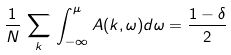<formula> <loc_0><loc_0><loc_500><loc_500>\frac { 1 } { N } \, \sum _ { k } \, \int _ { - \infty } ^ { \mu } A ( { k } , \omega ) d \omega = \frac { 1 - \delta } { 2 }</formula> 